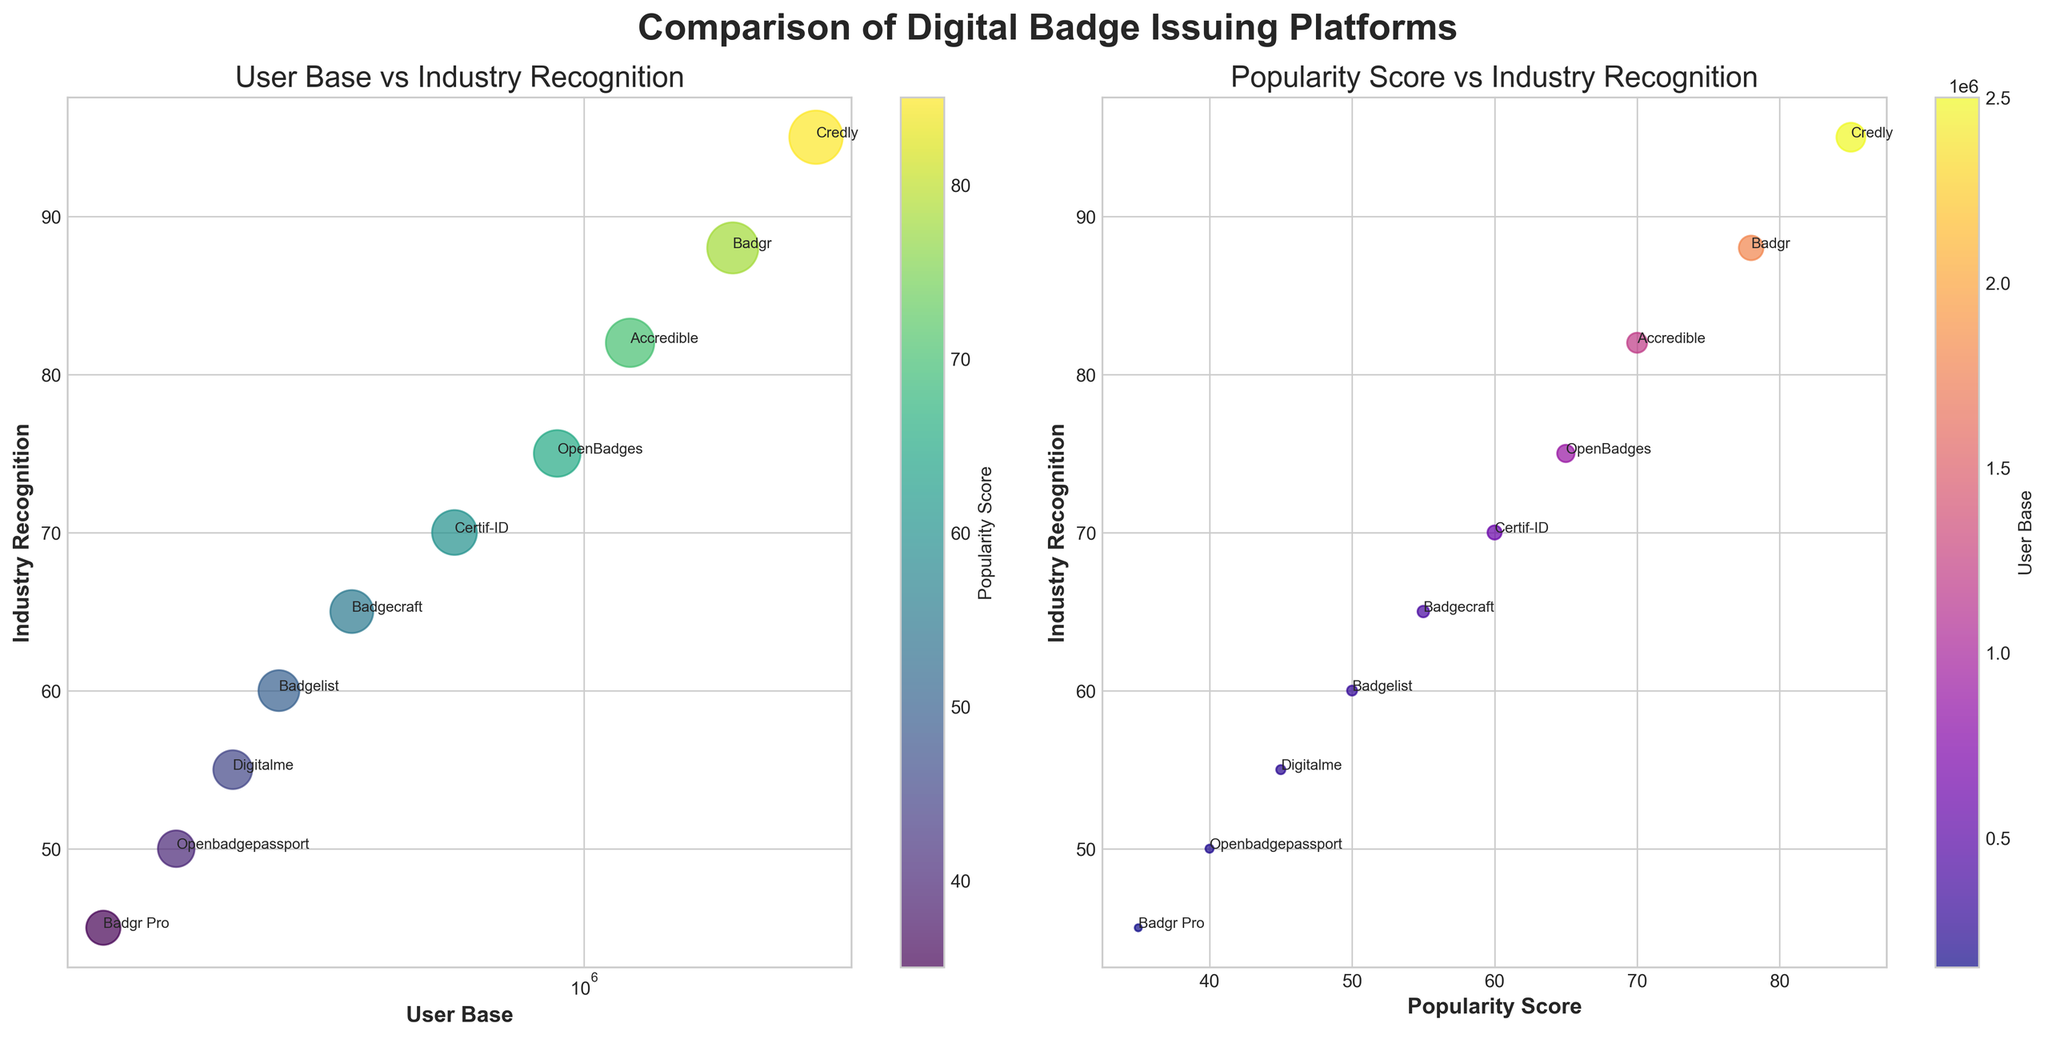What are the titles of the two subplots in the figure? The titles are displayed prominently above each subplot. The first subplot is titled "User Base vs Industry Recognition" and the second subplot is titled "Popularity Score vs Industry Recognition."
Answer: "User Base vs Industry Recognition" and "Popularity Score vs Industry Recognition" How many platforms are displayed in the figure? By counting the number of labels annotated on the bubbles in either of the subplots, we can identify that there are 10 platforms shown.
Answer: 10 Which platform has the largest user base? Looking at the x-axis on the "User Base vs Industry Recognition" subplot, the platform with the largest value on the user base axis is Credly.
Answer: Credly What's the relationship between user base and industry recognition for Credly? In the "User Base vs Industry Recognition" subplot, Credly is positioned at the highest user base value (2,500,000) and also shows a high industry recognition value (95). This indicates that Credly has both a large user base and high industry recognition.
Answer: Large user base and high industry recognition Which platform has the smallest user base and how recognized is it in the industry? In the "User Base vs Industry Recognition" subplot, Openbadgepassport has the smallest user base (200,000) along with an industry recognition score of 50.
Answer: Openbadgepassport with industry recognition of 50 Is there a correlation between popularity score and industry recognition? In the "Popularity Score vs Industry Recognition" subplot, there is a visible trend that as the popularity score increases, the industry recognition generally increases as well, indicating a positive correlation.
Answer: Positive correlation Which platform has the highest industry recognition score, and what is its popularity score? From the "User Base vs Industry Recognition" subplot, the platform with the highest industry recognition (95) is Credly, and it has a popularity score of 85.
Answer: Credly with a popularity score of 85 Describe the size of the bubbles in the "User Base vs Industry Recognition" subplot. In this subplot, bubble size represents the popularity score, with larger bubbles corresponding to higher popularity scores. For example, Credly has the largest bubble size with the highest popularity score (85).
Answer: Larger bubbles have a higher popularity score Which platform has the highest popularity score and what is its industry recognition? Referring to the second subplot, Credly has the highest popularity score (85) and it also has a high industry recognition score of 95.
Answer: Credly with a recognition score of 95 In the "Popularity Score vs Industry Recognition" chart, which platform has the lowest industry recognition and what is its user base? In this subplot, Badgr Pro has the lowest industry recognition (45), and its user base is 150,000 as indicated by the smaller bubble size and the annotation.
Answer: Badgr Pro with a user base of 150,000 